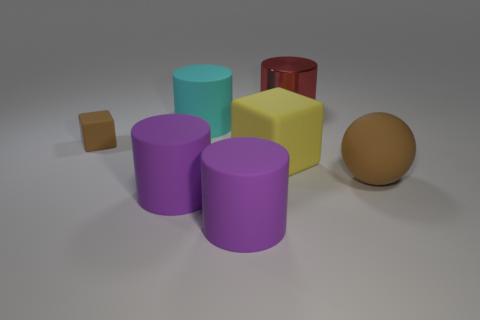Are there any other things that have the same material as the red thing?
Offer a terse response. No. How many things are left of the yellow matte thing?
Provide a short and direct response. 4. Do the large sphere and the tiny rubber thing have the same color?
Ensure brevity in your answer.  Yes. The big brown thing that is made of the same material as the cyan cylinder is what shape?
Your answer should be very brief. Sphere. Do the tiny brown matte thing to the left of the big brown ball and the big yellow thing have the same shape?
Keep it short and to the point. Yes. How many green things are rubber cylinders or spheres?
Your answer should be compact. 0. Is the number of objects to the left of the large red cylinder the same as the number of rubber things in front of the cyan cylinder?
Provide a succinct answer. Yes. There is a matte cylinder behind the big matte thing right of the cube on the right side of the large cyan cylinder; what color is it?
Keep it short and to the point. Cyan. Are there any other things of the same color as the tiny cube?
Offer a very short reply. Yes. What shape is the thing that is the same color as the large rubber ball?
Make the answer very short. Cube. 